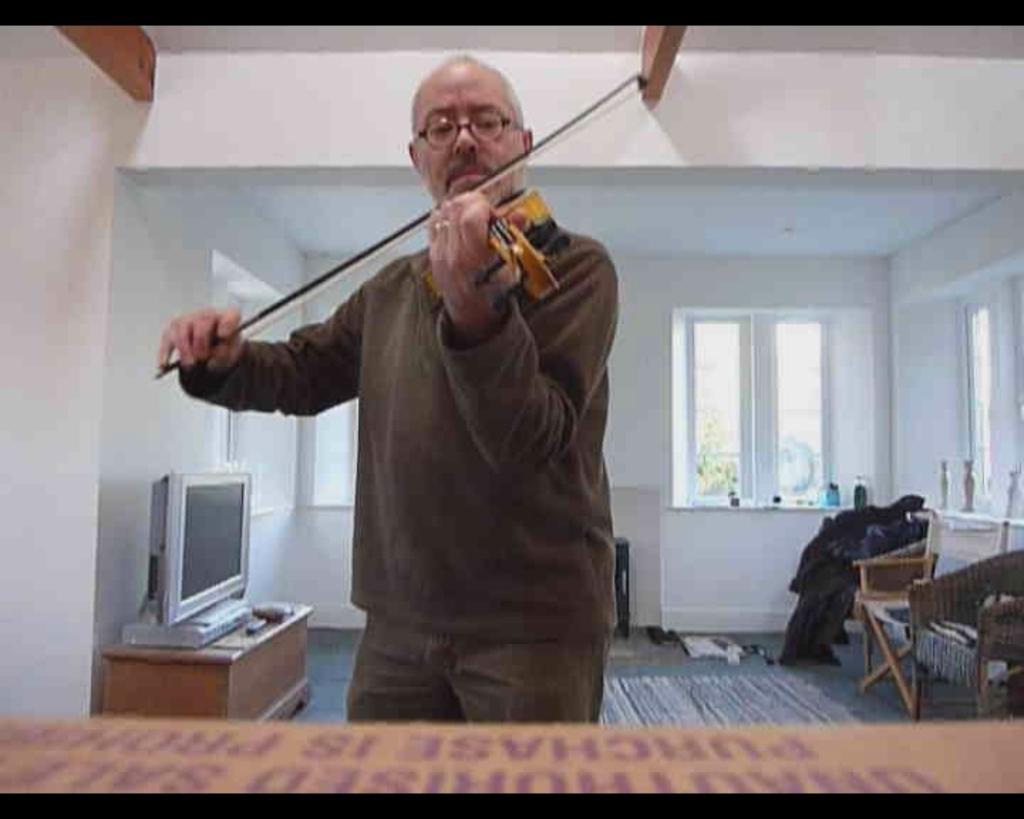Please provide a concise description of this image. In the center of the image we can see a man standing and playing a violin. At the bottom there is a board. In the background there are chairs and we can see a television placed on the stand. There are windows and a wall. 